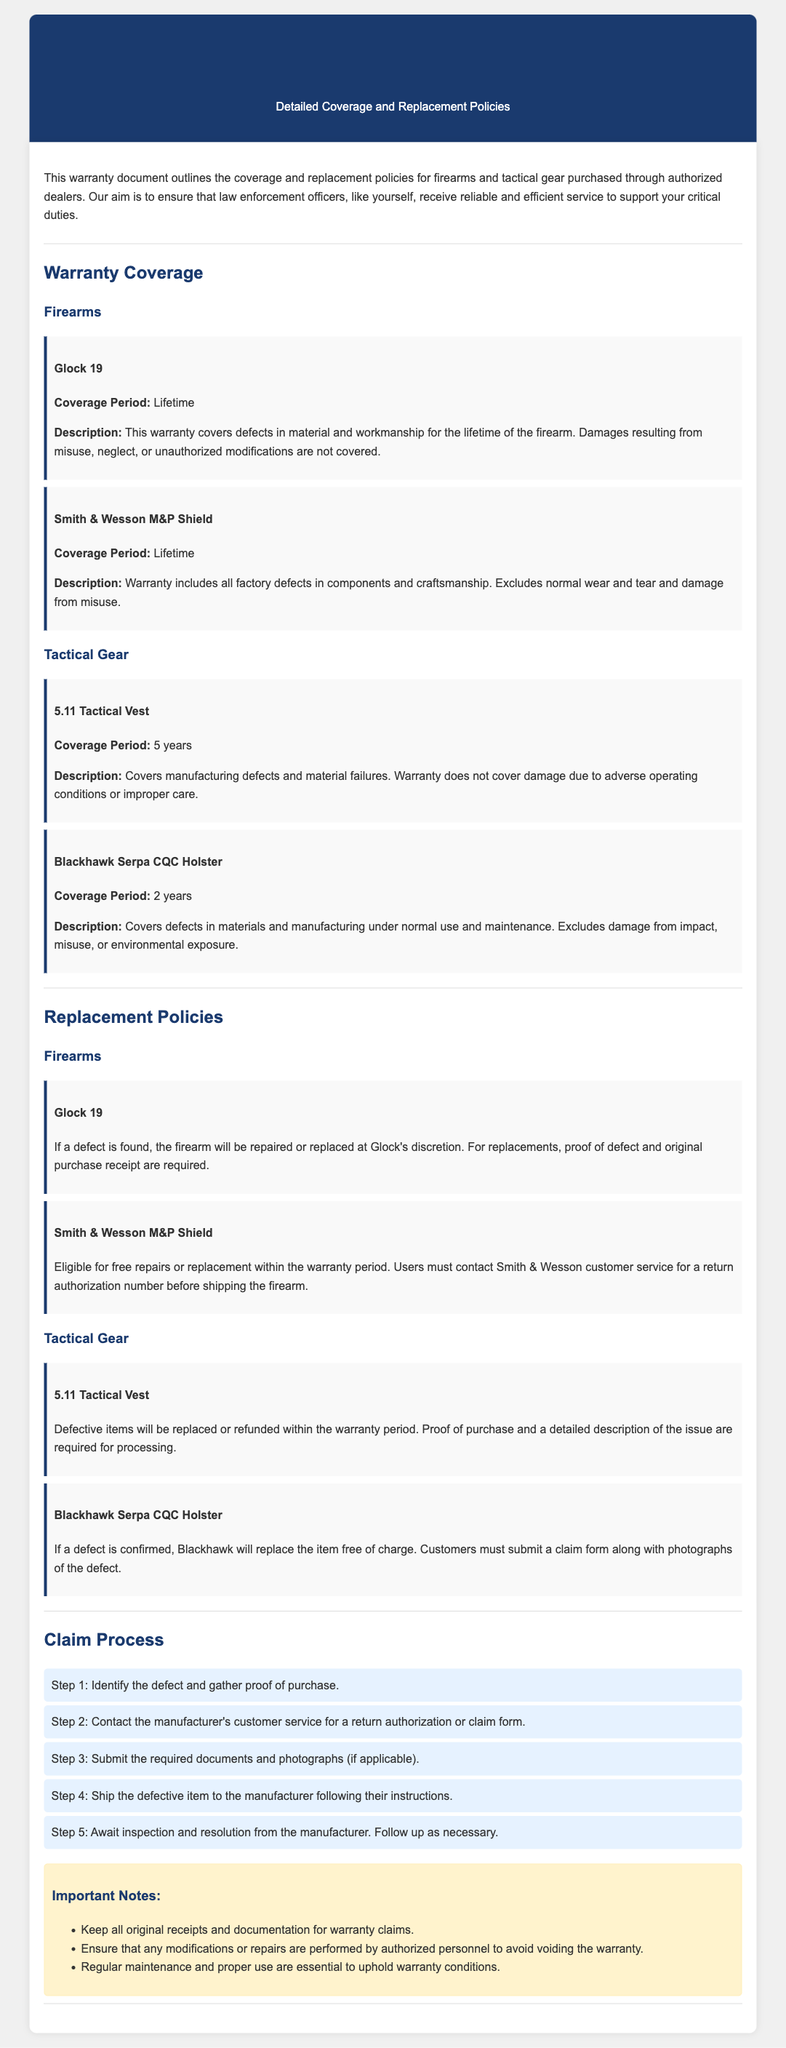What is the coverage period for Glock 19? The coverage period for Glock 19 is specified in the warranty document.
Answer: Lifetime What types of defects does the Smith & Wesson M&P Shield warranty cover? This part of the warranty details the specific types of issues covered under the warranty.
Answer: Factory defects How long is the warranty for the 5.11 Tactical Vest? The warranty document specifies the duration of coverage for each tactical gear item.
Answer: 5 years What must be submitted for a claim on the Blackhawk Serpa CQC Holster? This question focuses on the required documentation for a warranty claim, listed in the replacement policies section.
Answer: Claim form and photographs What is the first step in the claim process? The claim process outline details the sequential steps required to file a warranty claim.
Answer: Identify the defect and gather proof of purchase What happens if a defect is found in the Glock 19? The warranty explains the actions that will be taken if a defect is identified in Glock 19.
Answer: Repaired or replaced at Glock's discretion Are damages due to misuse covered under the Smith & Wesson M&P Shield warranty? This question refers to the exclusions mentioned in the warranty coverage for firearms, which includes misuse.
Answer: No Which authorized dealer conditions apply to the warranty? The introductory section of the warranty mentions particular requirements for purchase and claims.
Answer: Authorized dealers 